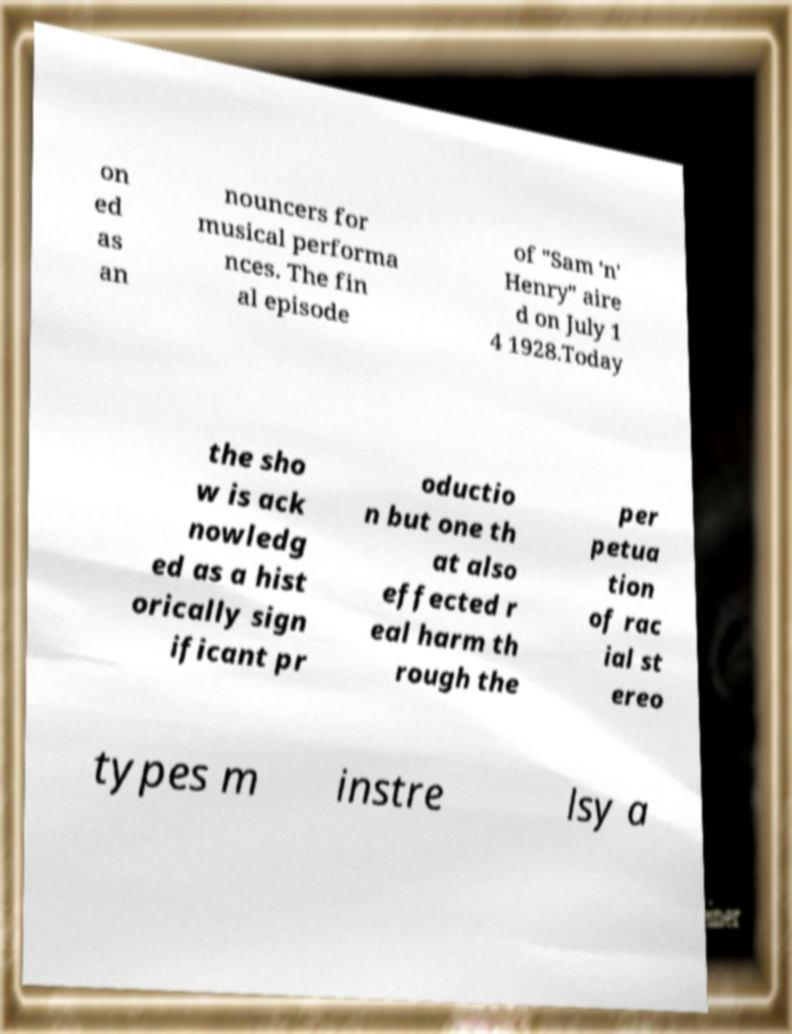Please read and relay the text visible in this image. What does it say? on ed as an nouncers for musical performa nces. The fin al episode of "Sam 'n' Henry" aire d on July 1 4 1928.Today the sho w is ack nowledg ed as a hist orically sign ificant pr oductio n but one th at also effected r eal harm th rough the per petua tion of rac ial st ereo types m instre lsy a 